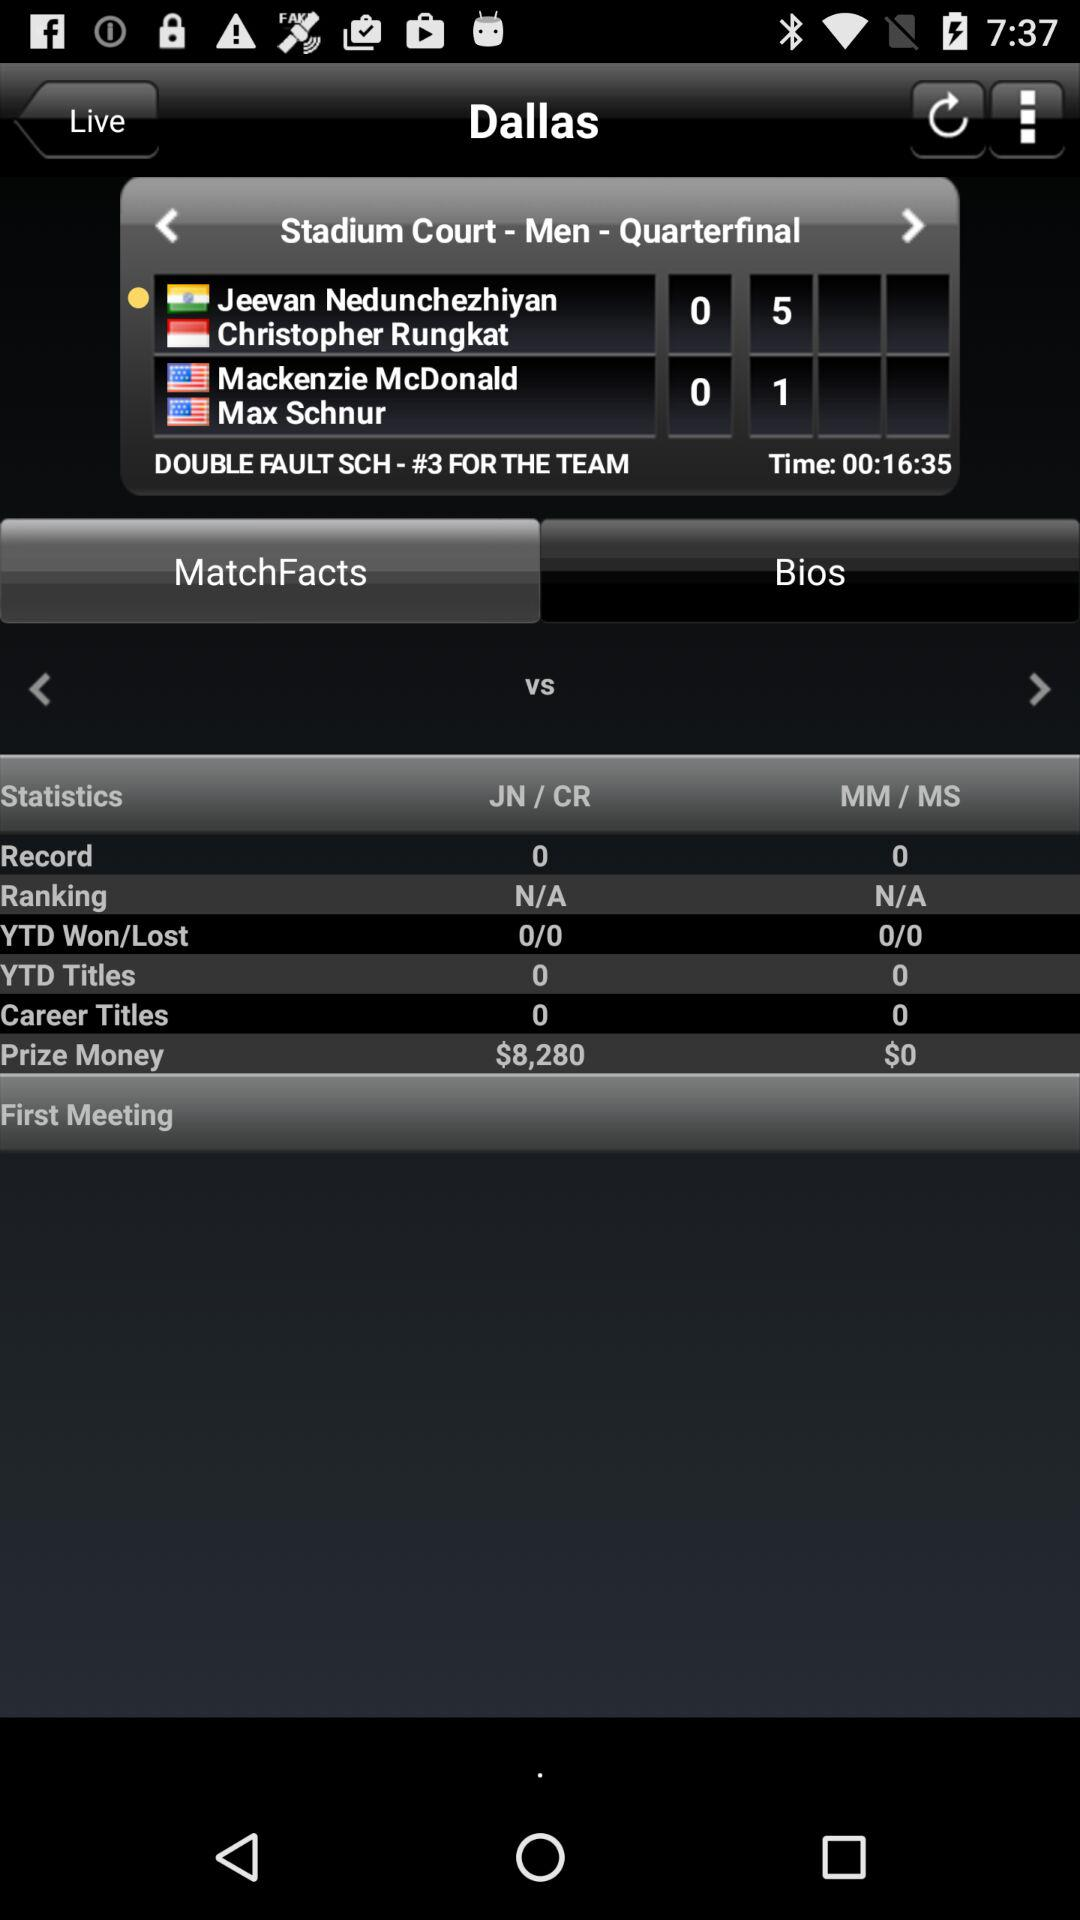What is the prize money for JN/CR given on the screen? The prize money for JN/CR given on the screen is $8,280. 